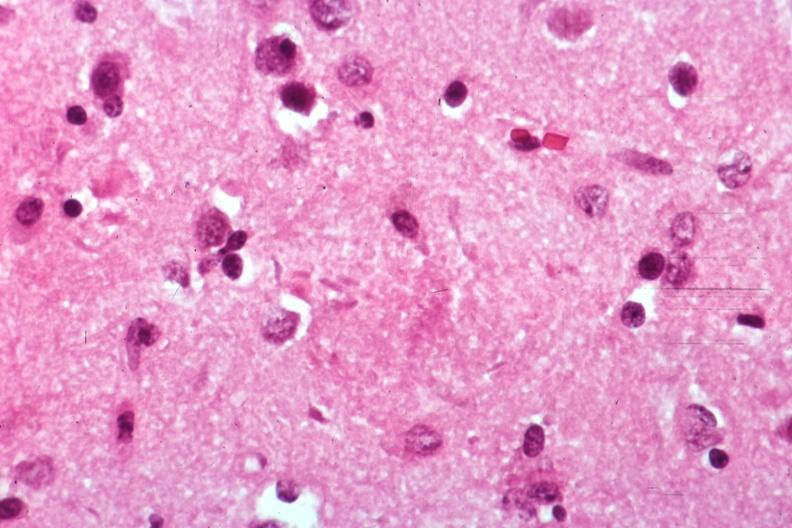what is present?
Answer the question using a single word or phrase. Brain 